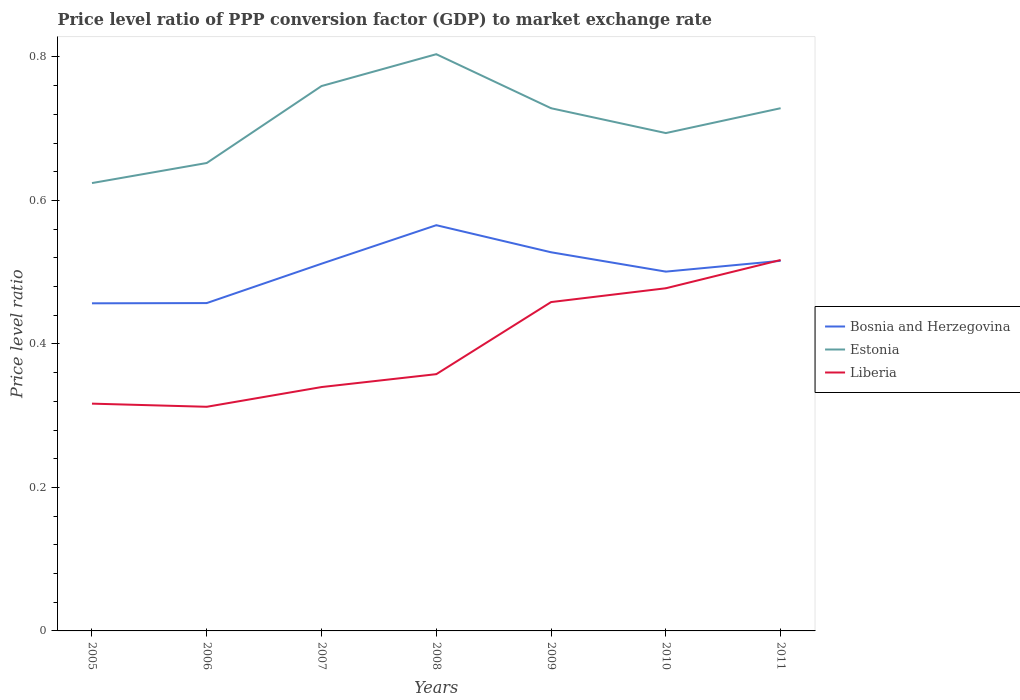Does the line corresponding to Liberia intersect with the line corresponding to Bosnia and Herzegovina?
Your response must be concise. Yes. Is the number of lines equal to the number of legend labels?
Your response must be concise. Yes. Across all years, what is the maximum price level ratio in Liberia?
Ensure brevity in your answer.  0.31. What is the total price level ratio in Estonia in the graph?
Your response must be concise. -0.04. What is the difference between the highest and the second highest price level ratio in Liberia?
Provide a succinct answer. 0.2. How many years are there in the graph?
Give a very brief answer. 7. What is the difference between two consecutive major ticks on the Y-axis?
Give a very brief answer. 0.2. What is the title of the graph?
Provide a succinct answer. Price level ratio of PPP conversion factor (GDP) to market exchange rate. Does "Middle East & North Africa (all income levels)" appear as one of the legend labels in the graph?
Offer a very short reply. No. What is the label or title of the X-axis?
Offer a terse response. Years. What is the label or title of the Y-axis?
Provide a short and direct response. Price level ratio. What is the Price level ratio in Bosnia and Herzegovina in 2005?
Provide a succinct answer. 0.46. What is the Price level ratio in Estonia in 2005?
Provide a short and direct response. 0.62. What is the Price level ratio of Liberia in 2005?
Offer a very short reply. 0.32. What is the Price level ratio in Bosnia and Herzegovina in 2006?
Keep it short and to the point. 0.46. What is the Price level ratio of Estonia in 2006?
Ensure brevity in your answer.  0.65. What is the Price level ratio of Liberia in 2006?
Offer a terse response. 0.31. What is the Price level ratio in Bosnia and Herzegovina in 2007?
Give a very brief answer. 0.51. What is the Price level ratio of Estonia in 2007?
Make the answer very short. 0.76. What is the Price level ratio in Liberia in 2007?
Offer a terse response. 0.34. What is the Price level ratio of Bosnia and Herzegovina in 2008?
Provide a short and direct response. 0.57. What is the Price level ratio in Estonia in 2008?
Offer a very short reply. 0.8. What is the Price level ratio of Liberia in 2008?
Your answer should be compact. 0.36. What is the Price level ratio in Bosnia and Herzegovina in 2009?
Your answer should be compact. 0.53. What is the Price level ratio of Estonia in 2009?
Make the answer very short. 0.73. What is the Price level ratio of Liberia in 2009?
Make the answer very short. 0.46. What is the Price level ratio in Bosnia and Herzegovina in 2010?
Offer a very short reply. 0.5. What is the Price level ratio in Estonia in 2010?
Ensure brevity in your answer.  0.69. What is the Price level ratio of Liberia in 2010?
Your answer should be very brief. 0.48. What is the Price level ratio in Bosnia and Herzegovina in 2011?
Your answer should be very brief. 0.52. What is the Price level ratio of Estonia in 2011?
Make the answer very short. 0.73. What is the Price level ratio of Liberia in 2011?
Your answer should be compact. 0.52. Across all years, what is the maximum Price level ratio of Bosnia and Herzegovina?
Your answer should be compact. 0.57. Across all years, what is the maximum Price level ratio in Estonia?
Your answer should be very brief. 0.8. Across all years, what is the maximum Price level ratio in Liberia?
Give a very brief answer. 0.52. Across all years, what is the minimum Price level ratio of Bosnia and Herzegovina?
Keep it short and to the point. 0.46. Across all years, what is the minimum Price level ratio of Estonia?
Give a very brief answer. 0.62. Across all years, what is the minimum Price level ratio in Liberia?
Your answer should be compact. 0.31. What is the total Price level ratio in Bosnia and Herzegovina in the graph?
Ensure brevity in your answer.  3.54. What is the total Price level ratio in Estonia in the graph?
Offer a terse response. 4.99. What is the total Price level ratio of Liberia in the graph?
Ensure brevity in your answer.  2.78. What is the difference between the Price level ratio of Bosnia and Herzegovina in 2005 and that in 2006?
Make the answer very short. -0. What is the difference between the Price level ratio of Estonia in 2005 and that in 2006?
Offer a very short reply. -0.03. What is the difference between the Price level ratio of Liberia in 2005 and that in 2006?
Your answer should be very brief. 0. What is the difference between the Price level ratio in Bosnia and Herzegovina in 2005 and that in 2007?
Make the answer very short. -0.06. What is the difference between the Price level ratio of Estonia in 2005 and that in 2007?
Provide a succinct answer. -0.14. What is the difference between the Price level ratio of Liberia in 2005 and that in 2007?
Your answer should be very brief. -0.02. What is the difference between the Price level ratio of Bosnia and Herzegovina in 2005 and that in 2008?
Provide a short and direct response. -0.11. What is the difference between the Price level ratio of Estonia in 2005 and that in 2008?
Give a very brief answer. -0.18. What is the difference between the Price level ratio of Liberia in 2005 and that in 2008?
Your answer should be very brief. -0.04. What is the difference between the Price level ratio of Bosnia and Herzegovina in 2005 and that in 2009?
Offer a terse response. -0.07. What is the difference between the Price level ratio of Estonia in 2005 and that in 2009?
Offer a terse response. -0.1. What is the difference between the Price level ratio in Liberia in 2005 and that in 2009?
Your answer should be very brief. -0.14. What is the difference between the Price level ratio in Bosnia and Herzegovina in 2005 and that in 2010?
Give a very brief answer. -0.04. What is the difference between the Price level ratio of Estonia in 2005 and that in 2010?
Your answer should be compact. -0.07. What is the difference between the Price level ratio of Liberia in 2005 and that in 2010?
Give a very brief answer. -0.16. What is the difference between the Price level ratio of Bosnia and Herzegovina in 2005 and that in 2011?
Give a very brief answer. -0.06. What is the difference between the Price level ratio of Estonia in 2005 and that in 2011?
Your response must be concise. -0.1. What is the difference between the Price level ratio in Liberia in 2005 and that in 2011?
Provide a short and direct response. -0.2. What is the difference between the Price level ratio in Bosnia and Herzegovina in 2006 and that in 2007?
Your answer should be compact. -0.05. What is the difference between the Price level ratio of Estonia in 2006 and that in 2007?
Your answer should be compact. -0.11. What is the difference between the Price level ratio in Liberia in 2006 and that in 2007?
Ensure brevity in your answer.  -0.03. What is the difference between the Price level ratio in Bosnia and Herzegovina in 2006 and that in 2008?
Provide a short and direct response. -0.11. What is the difference between the Price level ratio in Estonia in 2006 and that in 2008?
Ensure brevity in your answer.  -0.15. What is the difference between the Price level ratio of Liberia in 2006 and that in 2008?
Keep it short and to the point. -0.05. What is the difference between the Price level ratio in Bosnia and Herzegovina in 2006 and that in 2009?
Your answer should be very brief. -0.07. What is the difference between the Price level ratio of Estonia in 2006 and that in 2009?
Ensure brevity in your answer.  -0.08. What is the difference between the Price level ratio of Liberia in 2006 and that in 2009?
Keep it short and to the point. -0.15. What is the difference between the Price level ratio of Bosnia and Herzegovina in 2006 and that in 2010?
Offer a very short reply. -0.04. What is the difference between the Price level ratio in Estonia in 2006 and that in 2010?
Ensure brevity in your answer.  -0.04. What is the difference between the Price level ratio of Liberia in 2006 and that in 2010?
Your answer should be very brief. -0.17. What is the difference between the Price level ratio in Bosnia and Herzegovina in 2006 and that in 2011?
Offer a very short reply. -0.06. What is the difference between the Price level ratio of Estonia in 2006 and that in 2011?
Your answer should be compact. -0.08. What is the difference between the Price level ratio of Liberia in 2006 and that in 2011?
Offer a terse response. -0.2. What is the difference between the Price level ratio in Bosnia and Herzegovina in 2007 and that in 2008?
Give a very brief answer. -0.05. What is the difference between the Price level ratio of Estonia in 2007 and that in 2008?
Provide a succinct answer. -0.04. What is the difference between the Price level ratio in Liberia in 2007 and that in 2008?
Your answer should be compact. -0.02. What is the difference between the Price level ratio in Bosnia and Herzegovina in 2007 and that in 2009?
Offer a very short reply. -0.02. What is the difference between the Price level ratio of Estonia in 2007 and that in 2009?
Your answer should be compact. 0.03. What is the difference between the Price level ratio in Liberia in 2007 and that in 2009?
Ensure brevity in your answer.  -0.12. What is the difference between the Price level ratio in Bosnia and Herzegovina in 2007 and that in 2010?
Keep it short and to the point. 0.01. What is the difference between the Price level ratio in Estonia in 2007 and that in 2010?
Your answer should be very brief. 0.07. What is the difference between the Price level ratio in Liberia in 2007 and that in 2010?
Offer a terse response. -0.14. What is the difference between the Price level ratio of Bosnia and Herzegovina in 2007 and that in 2011?
Offer a terse response. -0. What is the difference between the Price level ratio in Estonia in 2007 and that in 2011?
Your answer should be compact. 0.03. What is the difference between the Price level ratio in Liberia in 2007 and that in 2011?
Provide a short and direct response. -0.18. What is the difference between the Price level ratio in Bosnia and Herzegovina in 2008 and that in 2009?
Your response must be concise. 0.04. What is the difference between the Price level ratio in Estonia in 2008 and that in 2009?
Your answer should be very brief. 0.08. What is the difference between the Price level ratio in Liberia in 2008 and that in 2009?
Your answer should be compact. -0.1. What is the difference between the Price level ratio of Bosnia and Herzegovina in 2008 and that in 2010?
Your answer should be very brief. 0.06. What is the difference between the Price level ratio of Estonia in 2008 and that in 2010?
Provide a short and direct response. 0.11. What is the difference between the Price level ratio in Liberia in 2008 and that in 2010?
Give a very brief answer. -0.12. What is the difference between the Price level ratio of Bosnia and Herzegovina in 2008 and that in 2011?
Offer a terse response. 0.05. What is the difference between the Price level ratio of Estonia in 2008 and that in 2011?
Offer a terse response. 0.08. What is the difference between the Price level ratio in Liberia in 2008 and that in 2011?
Your answer should be compact. -0.16. What is the difference between the Price level ratio in Bosnia and Herzegovina in 2009 and that in 2010?
Your answer should be compact. 0.03. What is the difference between the Price level ratio of Estonia in 2009 and that in 2010?
Provide a short and direct response. 0.03. What is the difference between the Price level ratio of Liberia in 2009 and that in 2010?
Your answer should be compact. -0.02. What is the difference between the Price level ratio in Bosnia and Herzegovina in 2009 and that in 2011?
Provide a succinct answer. 0.01. What is the difference between the Price level ratio of Estonia in 2009 and that in 2011?
Offer a terse response. -0. What is the difference between the Price level ratio of Liberia in 2009 and that in 2011?
Ensure brevity in your answer.  -0.06. What is the difference between the Price level ratio in Bosnia and Herzegovina in 2010 and that in 2011?
Give a very brief answer. -0.02. What is the difference between the Price level ratio in Estonia in 2010 and that in 2011?
Offer a very short reply. -0.03. What is the difference between the Price level ratio in Liberia in 2010 and that in 2011?
Keep it short and to the point. -0.04. What is the difference between the Price level ratio in Bosnia and Herzegovina in 2005 and the Price level ratio in Estonia in 2006?
Ensure brevity in your answer.  -0.2. What is the difference between the Price level ratio in Bosnia and Herzegovina in 2005 and the Price level ratio in Liberia in 2006?
Keep it short and to the point. 0.14. What is the difference between the Price level ratio in Estonia in 2005 and the Price level ratio in Liberia in 2006?
Provide a succinct answer. 0.31. What is the difference between the Price level ratio in Bosnia and Herzegovina in 2005 and the Price level ratio in Estonia in 2007?
Keep it short and to the point. -0.3. What is the difference between the Price level ratio of Bosnia and Herzegovina in 2005 and the Price level ratio of Liberia in 2007?
Offer a terse response. 0.12. What is the difference between the Price level ratio of Estonia in 2005 and the Price level ratio of Liberia in 2007?
Your answer should be compact. 0.28. What is the difference between the Price level ratio in Bosnia and Herzegovina in 2005 and the Price level ratio in Estonia in 2008?
Ensure brevity in your answer.  -0.35. What is the difference between the Price level ratio in Bosnia and Herzegovina in 2005 and the Price level ratio in Liberia in 2008?
Your answer should be compact. 0.1. What is the difference between the Price level ratio of Estonia in 2005 and the Price level ratio of Liberia in 2008?
Ensure brevity in your answer.  0.27. What is the difference between the Price level ratio in Bosnia and Herzegovina in 2005 and the Price level ratio in Estonia in 2009?
Your answer should be compact. -0.27. What is the difference between the Price level ratio in Bosnia and Herzegovina in 2005 and the Price level ratio in Liberia in 2009?
Keep it short and to the point. -0. What is the difference between the Price level ratio in Estonia in 2005 and the Price level ratio in Liberia in 2009?
Your answer should be very brief. 0.17. What is the difference between the Price level ratio in Bosnia and Herzegovina in 2005 and the Price level ratio in Estonia in 2010?
Keep it short and to the point. -0.24. What is the difference between the Price level ratio of Bosnia and Herzegovina in 2005 and the Price level ratio of Liberia in 2010?
Your answer should be very brief. -0.02. What is the difference between the Price level ratio in Estonia in 2005 and the Price level ratio in Liberia in 2010?
Offer a terse response. 0.15. What is the difference between the Price level ratio of Bosnia and Herzegovina in 2005 and the Price level ratio of Estonia in 2011?
Give a very brief answer. -0.27. What is the difference between the Price level ratio of Bosnia and Herzegovina in 2005 and the Price level ratio of Liberia in 2011?
Provide a succinct answer. -0.06. What is the difference between the Price level ratio in Estonia in 2005 and the Price level ratio in Liberia in 2011?
Make the answer very short. 0.11. What is the difference between the Price level ratio in Bosnia and Herzegovina in 2006 and the Price level ratio in Estonia in 2007?
Make the answer very short. -0.3. What is the difference between the Price level ratio in Bosnia and Herzegovina in 2006 and the Price level ratio in Liberia in 2007?
Keep it short and to the point. 0.12. What is the difference between the Price level ratio in Estonia in 2006 and the Price level ratio in Liberia in 2007?
Offer a very short reply. 0.31. What is the difference between the Price level ratio of Bosnia and Herzegovina in 2006 and the Price level ratio of Estonia in 2008?
Offer a terse response. -0.35. What is the difference between the Price level ratio of Bosnia and Herzegovina in 2006 and the Price level ratio of Liberia in 2008?
Your response must be concise. 0.1. What is the difference between the Price level ratio of Estonia in 2006 and the Price level ratio of Liberia in 2008?
Offer a very short reply. 0.29. What is the difference between the Price level ratio of Bosnia and Herzegovina in 2006 and the Price level ratio of Estonia in 2009?
Keep it short and to the point. -0.27. What is the difference between the Price level ratio of Bosnia and Herzegovina in 2006 and the Price level ratio of Liberia in 2009?
Keep it short and to the point. -0. What is the difference between the Price level ratio of Estonia in 2006 and the Price level ratio of Liberia in 2009?
Your response must be concise. 0.19. What is the difference between the Price level ratio in Bosnia and Herzegovina in 2006 and the Price level ratio in Estonia in 2010?
Give a very brief answer. -0.24. What is the difference between the Price level ratio in Bosnia and Herzegovina in 2006 and the Price level ratio in Liberia in 2010?
Provide a succinct answer. -0.02. What is the difference between the Price level ratio in Estonia in 2006 and the Price level ratio in Liberia in 2010?
Give a very brief answer. 0.17. What is the difference between the Price level ratio in Bosnia and Herzegovina in 2006 and the Price level ratio in Estonia in 2011?
Make the answer very short. -0.27. What is the difference between the Price level ratio of Bosnia and Herzegovina in 2006 and the Price level ratio of Liberia in 2011?
Offer a very short reply. -0.06. What is the difference between the Price level ratio of Estonia in 2006 and the Price level ratio of Liberia in 2011?
Make the answer very short. 0.14. What is the difference between the Price level ratio of Bosnia and Herzegovina in 2007 and the Price level ratio of Estonia in 2008?
Offer a terse response. -0.29. What is the difference between the Price level ratio of Bosnia and Herzegovina in 2007 and the Price level ratio of Liberia in 2008?
Provide a succinct answer. 0.15. What is the difference between the Price level ratio of Estonia in 2007 and the Price level ratio of Liberia in 2008?
Your answer should be very brief. 0.4. What is the difference between the Price level ratio of Bosnia and Herzegovina in 2007 and the Price level ratio of Estonia in 2009?
Your answer should be very brief. -0.22. What is the difference between the Price level ratio in Bosnia and Herzegovina in 2007 and the Price level ratio in Liberia in 2009?
Give a very brief answer. 0.05. What is the difference between the Price level ratio in Estonia in 2007 and the Price level ratio in Liberia in 2009?
Offer a very short reply. 0.3. What is the difference between the Price level ratio in Bosnia and Herzegovina in 2007 and the Price level ratio in Estonia in 2010?
Your answer should be very brief. -0.18. What is the difference between the Price level ratio of Bosnia and Herzegovina in 2007 and the Price level ratio of Liberia in 2010?
Provide a short and direct response. 0.03. What is the difference between the Price level ratio in Estonia in 2007 and the Price level ratio in Liberia in 2010?
Ensure brevity in your answer.  0.28. What is the difference between the Price level ratio in Bosnia and Herzegovina in 2007 and the Price level ratio in Estonia in 2011?
Your answer should be very brief. -0.22. What is the difference between the Price level ratio in Bosnia and Herzegovina in 2007 and the Price level ratio in Liberia in 2011?
Provide a short and direct response. -0.01. What is the difference between the Price level ratio in Estonia in 2007 and the Price level ratio in Liberia in 2011?
Keep it short and to the point. 0.24. What is the difference between the Price level ratio of Bosnia and Herzegovina in 2008 and the Price level ratio of Estonia in 2009?
Provide a short and direct response. -0.16. What is the difference between the Price level ratio in Bosnia and Herzegovina in 2008 and the Price level ratio in Liberia in 2009?
Make the answer very short. 0.11. What is the difference between the Price level ratio of Estonia in 2008 and the Price level ratio of Liberia in 2009?
Offer a terse response. 0.35. What is the difference between the Price level ratio of Bosnia and Herzegovina in 2008 and the Price level ratio of Estonia in 2010?
Give a very brief answer. -0.13. What is the difference between the Price level ratio in Bosnia and Herzegovina in 2008 and the Price level ratio in Liberia in 2010?
Ensure brevity in your answer.  0.09. What is the difference between the Price level ratio of Estonia in 2008 and the Price level ratio of Liberia in 2010?
Provide a short and direct response. 0.33. What is the difference between the Price level ratio in Bosnia and Herzegovina in 2008 and the Price level ratio in Estonia in 2011?
Your answer should be compact. -0.16. What is the difference between the Price level ratio of Bosnia and Herzegovina in 2008 and the Price level ratio of Liberia in 2011?
Ensure brevity in your answer.  0.05. What is the difference between the Price level ratio in Estonia in 2008 and the Price level ratio in Liberia in 2011?
Give a very brief answer. 0.29. What is the difference between the Price level ratio of Bosnia and Herzegovina in 2009 and the Price level ratio of Estonia in 2010?
Give a very brief answer. -0.17. What is the difference between the Price level ratio in Bosnia and Herzegovina in 2009 and the Price level ratio in Liberia in 2010?
Give a very brief answer. 0.05. What is the difference between the Price level ratio in Estonia in 2009 and the Price level ratio in Liberia in 2010?
Provide a succinct answer. 0.25. What is the difference between the Price level ratio of Bosnia and Herzegovina in 2009 and the Price level ratio of Estonia in 2011?
Offer a very short reply. -0.2. What is the difference between the Price level ratio in Bosnia and Herzegovina in 2009 and the Price level ratio in Liberia in 2011?
Give a very brief answer. 0.01. What is the difference between the Price level ratio of Estonia in 2009 and the Price level ratio of Liberia in 2011?
Your response must be concise. 0.21. What is the difference between the Price level ratio of Bosnia and Herzegovina in 2010 and the Price level ratio of Estonia in 2011?
Offer a terse response. -0.23. What is the difference between the Price level ratio in Bosnia and Herzegovina in 2010 and the Price level ratio in Liberia in 2011?
Offer a very short reply. -0.02. What is the difference between the Price level ratio of Estonia in 2010 and the Price level ratio of Liberia in 2011?
Make the answer very short. 0.18. What is the average Price level ratio of Bosnia and Herzegovina per year?
Provide a short and direct response. 0.51. What is the average Price level ratio in Estonia per year?
Give a very brief answer. 0.71. What is the average Price level ratio in Liberia per year?
Your answer should be compact. 0.4. In the year 2005, what is the difference between the Price level ratio of Bosnia and Herzegovina and Price level ratio of Estonia?
Your answer should be very brief. -0.17. In the year 2005, what is the difference between the Price level ratio in Bosnia and Herzegovina and Price level ratio in Liberia?
Keep it short and to the point. 0.14. In the year 2005, what is the difference between the Price level ratio of Estonia and Price level ratio of Liberia?
Your answer should be compact. 0.31. In the year 2006, what is the difference between the Price level ratio in Bosnia and Herzegovina and Price level ratio in Estonia?
Provide a short and direct response. -0.2. In the year 2006, what is the difference between the Price level ratio in Bosnia and Herzegovina and Price level ratio in Liberia?
Ensure brevity in your answer.  0.14. In the year 2006, what is the difference between the Price level ratio of Estonia and Price level ratio of Liberia?
Ensure brevity in your answer.  0.34. In the year 2007, what is the difference between the Price level ratio in Bosnia and Herzegovina and Price level ratio in Estonia?
Your answer should be compact. -0.25. In the year 2007, what is the difference between the Price level ratio in Bosnia and Herzegovina and Price level ratio in Liberia?
Make the answer very short. 0.17. In the year 2007, what is the difference between the Price level ratio in Estonia and Price level ratio in Liberia?
Keep it short and to the point. 0.42. In the year 2008, what is the difference between the Price level ratio of Bosnia and Herzegovina and Price level ratio of Estonia?
Give a very brief answer. -0.24. In the year 2008, what is the difference between the Price level ratio in Bosnia and Herzegovina and Price level ratio in Liberia?
Provide a succinct answer. 0.21. In the year 2008, what is the difference between the Price level ratio of Estonia and Price level ratio of Liberia?
Offer a very short reply. 0.45. In the year 2009, what is the difference between the Price level ratio in Bosnia and Herzegovina and Price level ratio in Estonia?
Provide a short and direct response. -0.2. In the year 2009, what is the difference between the Price level ratio in Bosnia and Herzegovina and Price level ratio in Liberia?
Offer a very short reply. 0.07. In the year 2009, what is the difference between the Price level ratio in Estonia and Price level ratio in Liberia?
Your response must be concise. 0.27. In the year 2010, what is the difference between the Price level ratio in Bosnia and Herzegovina and Price level ratio in Estonia?
Make the answer very short. -0.19. In the year 2010, what is the difference between the Price level ratio in Bosnia and Herzegovina and Price level ratio in Liberia?
Make the answer very short. 0.02. In the year 2010, what is the difference between the Price level ratio of Estonia and Price level ratio of Liberia?
Provide a short and direct response. 0.22. In the year 2011, what is the difference between the Price level ratio in Bosnia and Herzegovina and Price level ratio in Estonia?
Offer a terse response. -0.21. In the year 2011, what is the difference between the Price level ratio of Bosnia and Herzegovina and Price level ratio of Liberia?
Offer a very short reply. -0. In the year 2011, what is the difference between the Price level ratio of Estonia and Price level ratio of Liberia?
Give a very brief answer. 0.21. What is the ratio of the Price level ratio of Bosnia and Herzegovina in 2005 to that in 2006?
Your answer should be compact. 1. What is the ratio of the Price level ratio in Estonia in 2005 to that in 2006?
Keep it short and to the point. 0.96. What is the ratio of the Price level ratio in Liberia in 2005 to that in 2006?
Offer a terse response. 1.01. What is the ratio of the Price level ratio in Bosnia and Herzegovina in 2005 to that in 2007?
Your answer should be compact. 0.89. What is the ratio of the Price level ratio in Estonia in 2005 to that in 2007?
Your response must be concise. 0.82. What is the ratio of the Price level ratio of Liberia in 2005 to that in 2007?
Provide a short and direct response. 0.93. What is the ratio of the Price level ratio of Bosnia and Herzegovina in 2005 to that in 2008?
Offer a terse response. 0.81. What is the ratio of the Price level ratio of Estonia in 2005 to that in 2008?
Make the answer very short. 0.78. What is the ratio of the Price level ratio of Liberia in 2005 to that in 2008?
Make the answer very short. 0.89. What is the ratio of the Price level ratio of Bosnia and Herzegovina in 2005 to that in 2009?
Ensure brevity in your answer.  0.87. What is the ratio of the Price level ratio of Estonia in 2005 to that in 2009?
Offer a very short reply. 0.86. What is the ratio of the Price level ratio of Liberia in 2005 to that in 2009?
Provide a succinct answer. 0.69. What is the ratio of the Price level ratio in Bosnia and Herzegovina in 2005 to that in 2010?
Provide a short and direct response. 0.91. What is the ratio of the Price level ratio in Estonia in 2005 to that in 2010?
Provide a short and direct response. 0.9. What is the ratio of the Price level ratio in Liberia in 2005 to that in 2010?
Your answer should be very brief. 0.66. What is the ratio of the Price level ratio in Bosnia and Herzegovina in 2005 to that in 2011?
Your response must be concise. 0.89. What is the ratio of the Price level ratio of Estonia in 2005 to that in 2011?
Provide a short and direct response. 0.86. What is the ratio of the Price level ratio in Liberia in 2005 to that in 2011?
Your answer should be compact. 0.61. What is the ratio of the Price level ratio in Bosnia and Herzegovina in 2006 to that in 2007?
Offer a very short reply. 0.89. What is the ratio of the Price level ratio in Estonia in 2006 to that in 2007?
Offer a very short reply. 0.86. What is the ratio of the Price level ratio in Liberia in 2006 to that in 2007?
Your answer should be very brief. 0.92. What is the ratio of the Price level ratio in Bosnia and Herzegovina in 2006 to that in 2008?
Offer a very short reply. 0.81. What is the ratio of the Price level ratio in Estonia in 2006 to that in 2008?
Offer a very short reply. 0.81. What is the ratio of the Price level ratio in Liberia in 2006 to that in 2008?
Provide a short and direct response. 0.87. What is the ratio of the Price level ratio of Bosnia and Herzegovina in 2006 to that in 2009?
Keep it short and to the point. 0.87. What is the ratio of the Price level ratio of Estonia in 2006 to that in 2009?
Provide a short and direct response. 0.9. What is the ratio of the Price level ratio of Liberia in 2006 to that in 2009?
Ensure brevity in your answer.  0.68. What is the ratio of the Price level ratio of Bosnia and Herzegovina in 2006 to that in 2010?
Give a very brief answer. 0.91. What is the ratio of the Price level ratio of Estonia in 2006 to that in 2010?
Your answer should be very brief. 0.94. What is the ratio of the Price level ratio of Liberia in 2006 to that in 2010?
Provide a short and direct response. 0.65. What is the ratio of the Price level ratio of Bosnia and Herzegovina in 2006 to that in 2011?
Your answer should be compact. 0.89. What is the ratio of the Price level ratio of Estonia in 2006 to that in 2011?
Your answer should be very brief. 0.9. What is the ratio of the Price level ratio in Liberia in 2006 to that in 2011?
Your answer should be very brief. 0.6. What is the ratio of the Price level ratio in Bosnia and Herzegovina in 2007 to that in 2008?
Offer a terse response. 0.91. What is the ratio of the Price level ratio in Estonia in 2007 to that in 2008?
Ensure brevity in your answer.  0.94. What is the ratio of the Price level ratio in Liberia in 2007 to that in 2008?
Provide a succinct answer. 0.95. What is the ratio of the Price level ratio of Bosnia and Herzegovina in 2007 to that in 2009?
Your answer should be very brief. 0.97. What is the ratio of the Price level ratio of Estonia in 2007 to that in 2009?
Your answer should be very brief. 1.04. What is the ratio of the Price level ratio in Liberia in 2007 to that in 2009?
Give a very brief answer. 0.74. What is the ratio of the Price level ratio in Estonia in 2007 to that in 2010?
Offer a terse response. 1.09. What is the ratio of the Price level ratio in Liberia in 2007 to that in 2010?
Offer a very short reply. 0.71. What is the ratio of the Price level ratio in Bosnia and Herzegovina in 2007 to that in 2011?
Make the answer very short. 0.99. What is the ratio of the Price level ratio of Estonia in 2007 to that in 2011?
Keep it short and to the point. 1.04. What is the ratio of the Price level ratio in Liberia in 2007 to that in 2011?
Make the answer very short. 0.66. What is the ratio of the Price level ratio in Bosnia and Herzegovina in 2008 to that in 2009?
Keep it short and to the point. 1.07. What is the ratio of the Price level ratio of Estonia in 2008 to that in 2009?
Give a very brief answer. 1.1. What is the ratio of the Price level ratio of Liberia in 2008 to that in 2009?
Give a very brief answer. 0.78. What is the ratio of the Price level ratio in Bosnia and Herzegovina in 2008 to that in 2010?
Keep it short and to the point. 1.13. What is the ratio of the Price level ratio of Estonia in 2008 to that in 2010?
Your answer should be very brief. 1.16. What is the ratio of the Price level ratio in Liberia in 2008 to that in 2010?
Keep it short and to the point. 0.75. What is the ratio of the Price level ratio in Bosnia and Herzegovina in 2008 to that in 2011?
Your response must be concise. 1.1. What is the ratio of the Price level ratio of Estonia in 2008 to that in 2011?
Your answer should be compact. 1.1. What is the ratio of the Price level ratio of Liberia in 2008 to that in 2011?
Ensure brevity in your answer.  0.69. What is the ratio of the Price level ratio in Bosnia and Herzegovina in 2009 to that in 2010?
Offer a terse response. 1.05. What is the ratio of the Price level ratio of Estonia in 2009 to that in 2010?
Keep it short and to the point. 1.05. What is the ratio of the Price level ratio in Liberia in 2009 to that in 2010?
Offer a very short reply. 0.96. What is the ratio of the Price level ratio of Bosnia and Herzegovina in 2009 to that in 2011?
Offer a terse response. 1.02. What is the ratio of the Price level ratio in Liberia in 2009 to that in 2011?
Your answer should be compact. 0.89. What is the ratio of the Price level ratio of Bosnia and Herzegovina in 2010 to that in 2011?
Give a very brief answer. 0.97. What is the ratio of the Price level ratio in Liberia in 2010 to that in 2011?
Your response must be concise. 0.92. What is the difference between the highest and the second highest Price level ratio in Bosnia and Herzegovina?
Provide a succinct answer. 0.04. What is the difference between the highest and the second highest Price level ratio of Estonia?
Offer a terse response. 0.04. What is the difference between the highest and the second highest Price level ratio in Liberia?
Your answer should be very brief. 0.04. What is the difference between the highest and the lowest Price level ratio in Bosnia and Herzegovina?
Your answer should be very brief. 0.11. What is the difference between the highest and the lowest Price level ratio in Estonia?
Keep it short and to the point. 0.18. What is the difference between the highest and the lowest Price level ratio of Liberia?
Your response must be concise. 0.2. 